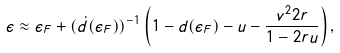Convert formula to latex. <formula><loc_0><loc_0><loc_500><loc_500>\epsilon \approx \epsilon _ { F } + ( \dot { d } ( \epsilon _ { F } ) ) ^ { - 1 } \left ( 1 - d ( \epsilon _ { F } ) - u - \frac { v ^ { 2 } 2 r } { 1 - 2 r u } \right ) ,</formula> 